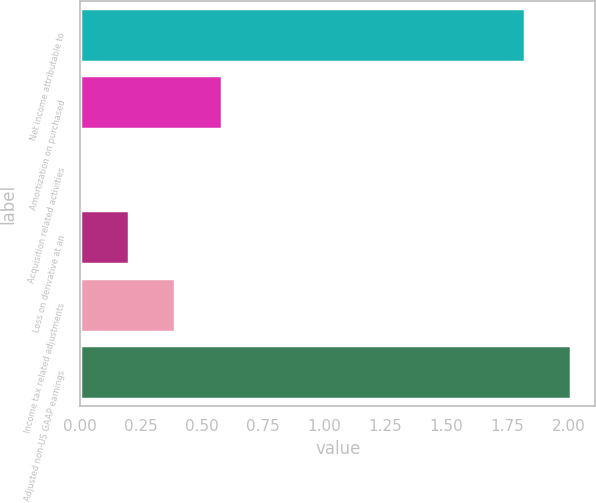Convert chart to OTSL. <chart><loc_0><loc_0><loc_500><loc_500><bar_chart><fcel>Net income attributable to<fcel>Amortization on purchased<fcel>Acquisition related activities<fcel>Loss on derivative at an<fcel>Income tax related adjustments<fcel>Adjusted non-US GAAP earnings<nl><fcel>1.82<fcel>0.58<fcel>0.01<fcel>0.2<fcel>0.39<fcel>2.01<nl></chart> 